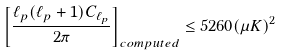Convert formula to latex. <formula><loc_0><loc_0><loc_500><loc_500>\left [ \frac { \ell _ { p } ( \ell _ { p } + 1 ) C _ { \ell _ { p } } } { 2 \pi } \right ] _ { c o m p u t e d } \leq 5 2 6 0 ( \mu K ) ^ { 2 }</formula> 